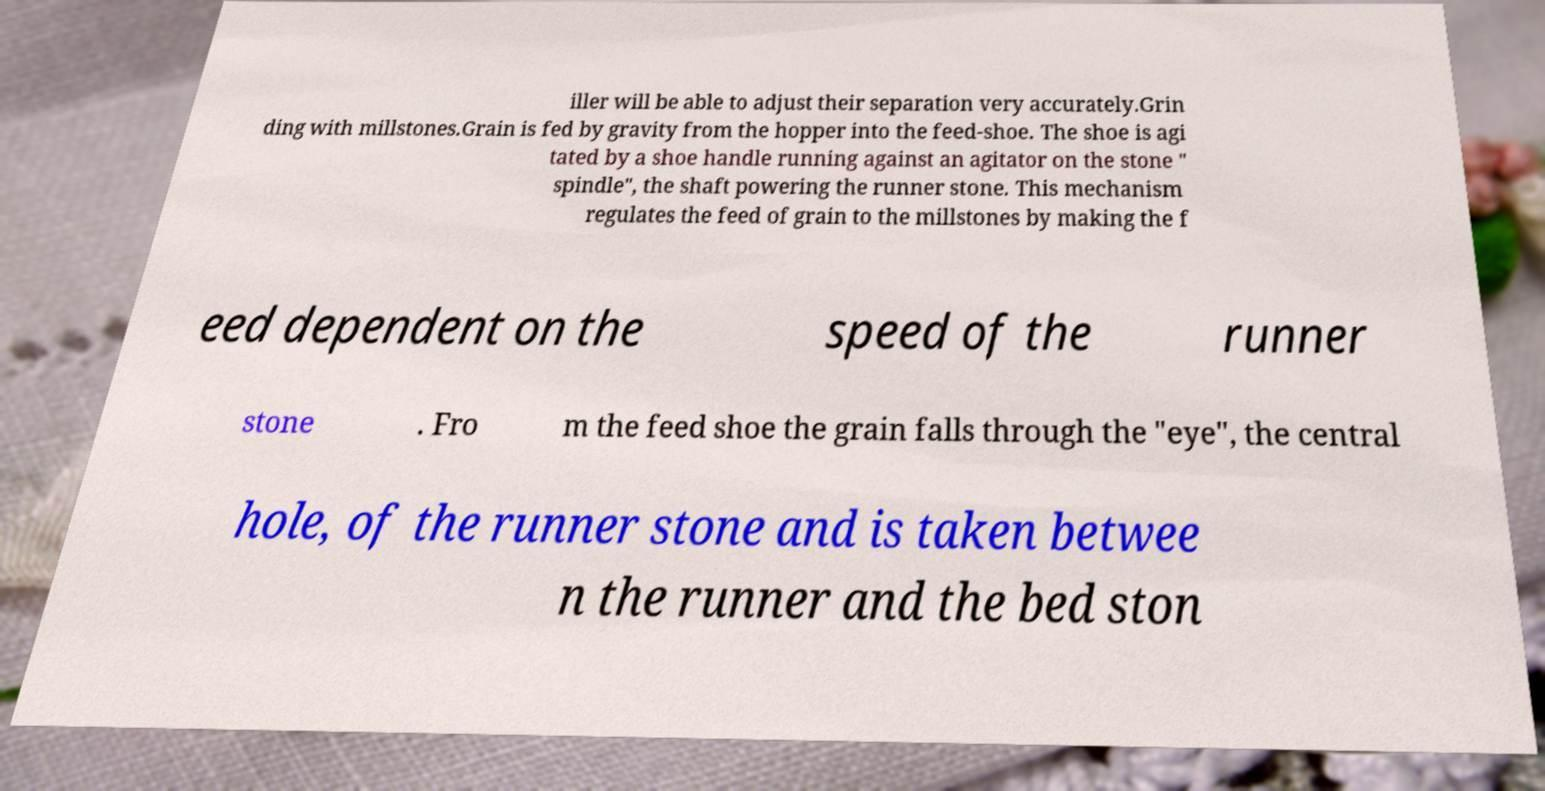Please identify and transcribe the text found in this image. iller will be able to adjust their separation very accurately.Grin ding with millstones.Grain is fed by gravity from the hopper into the feed-shoe. The shoe is agi tated by a shoe handle running against an agitator on the stone " spindle", the shaft powering the runner stone. This mechanism regulates the feed of grain to the millstones by making the f eed dependent on the speed of the runner stone . Fro m the feed shoe the grain falls through the "eye", the central hole, of the runner stone and is taken betwee n the runner and the bed ston 